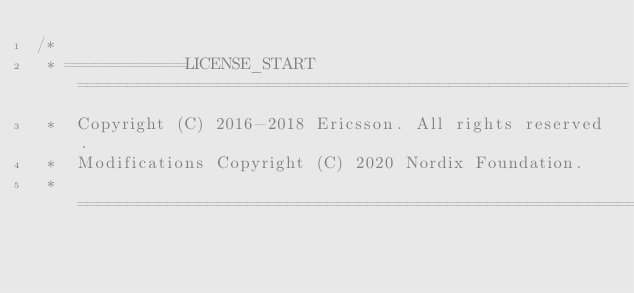Convert code to text. <code><loc_0><loc_0><loc_500><loc_500><_JavaScript_>/*
 * ============LICENSE_START=======================================================
 *  Copyright (C) 2016-2018 Ericsson. All rights reserved.
 *  Modifications Copyright (C) 2020 Nordix Foundation.
 * ================================================================================</code> 